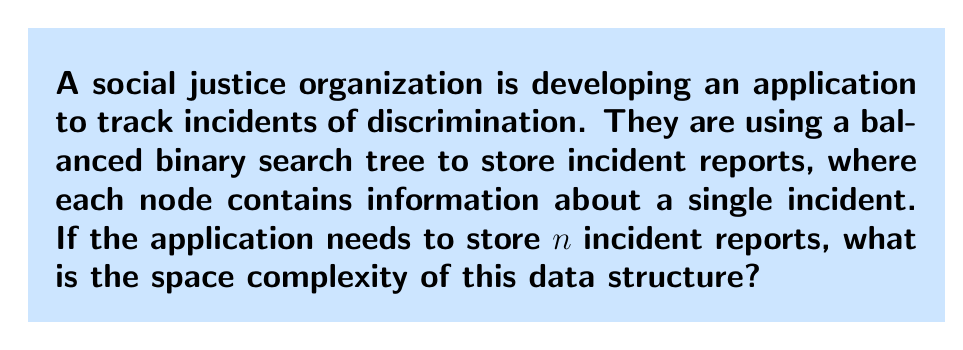Give your solution to this math problem. To determine the space complexity, we need to analyze how the storage requirements grow with the number of incident reports ($n$). Let's break it down step-by-step:

1) In a balanced binary search tree, each node typically contains:
   - The data (incident report information)
   - A pointer to the left child
   - A pointer to the right child

2) Let's assume each incident report and each pointer takes constant space, say $c$.

3) The total space for each node is then $3c$ (data + 2 pointers).

4) In a balanced binary search tree with $n$ nodes:
   - The tree has a height of $\log_2(n)$ (rounded up)
   - Each level of the tree is fully filled, except possibly the last level

5) The total number of nodes is exactly $n$, as each incident report is stored in one node.

6) Therefore, the total space used is:

   $$\text{Total Space} = n \cdot 3c = 3cn$$

7) In big O notation, we drop constant factors, so the space complexity is $O(n)$.

This linear space complexity means that the storage requirement grows proportionally with the number of incident reports, which is efficient for the organization's needs while allowing quick access and updates to the data.
Answer: $O(n)$ 